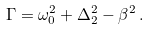<formula> <loc_0><loc_0><loc_500><loc_500>\Gamma = \omega _ { 0 } ^ { 2 } + \Delta _ { 2 } ^ { 2 } - \beta ^ { 2 } \, .</formula> 